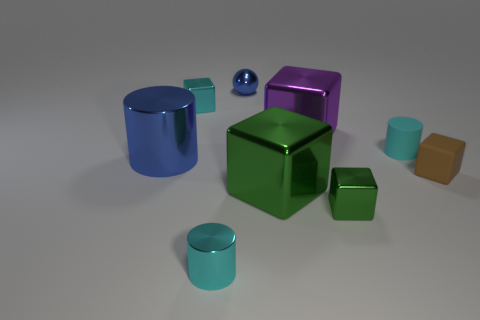What is the large green thing made of?
Your answer should be compact. Metal. What number of yellow shiny things are the same size as the blue ball?
Offer a terse response. 0. What shape is the small object that is the same color as the big metal cylinder?
Keep it short and to the point. Sphere. Are there any small red shiny objects of the same shape as the cyan rubber object?
Your response must be concise. No. There is a ball that is the same size as the cyan metal cylinder; what color is it?
Your answer should be compact. Blue. The large cube in front of the tiny cylinder behind the large blue thing is what color?
Make the answer very short. Green. Does the tiny block on the left side of the purple metal block have the same color as the small rubber block?
Provide a short and direct response. No. What is the shape of the cyan shiny object behind the green shiny cube that is to the left of the big metallic block behind the brown object?
Provide a short and direct response. Cube. There is a cyan cylinder that is behind the small brown object; what number of blue shiny cylinders are right of it?
Offer a very short reply. 0. Is the material of the tiny brown thing the same as the large green block?
Your response must be concise. No. 